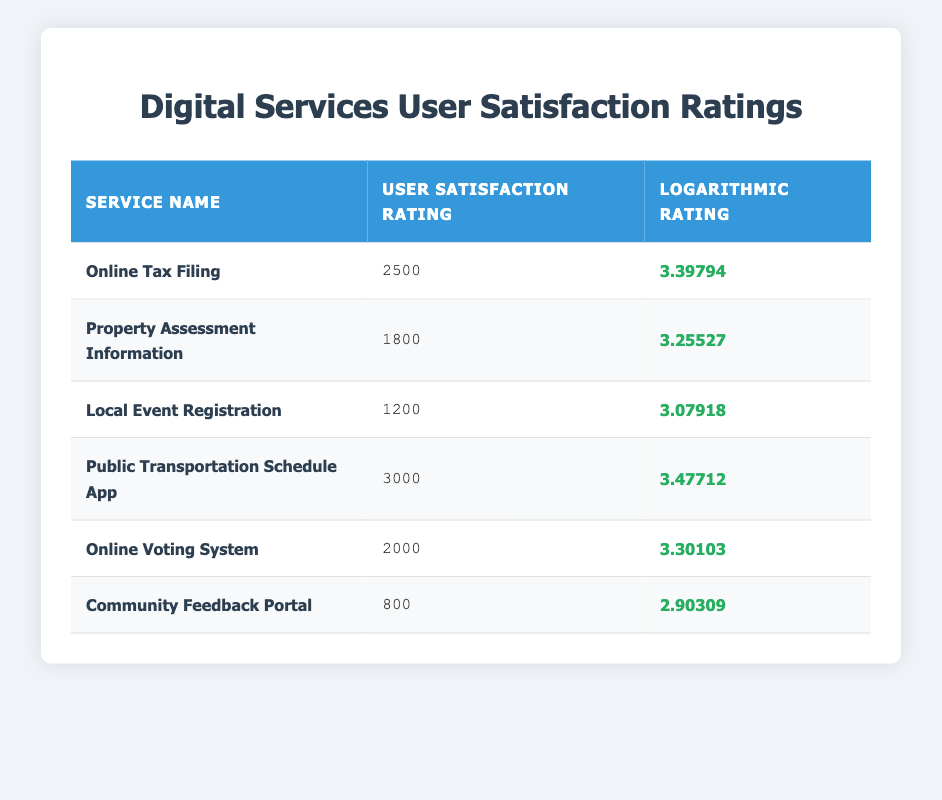What is the user satisfaction rating of the "Public Transportation Schedule App"? The table lists the "Public Transportation Schedule App" with a user satisfaction rating of 3000.
Answer: 3000 Which digital service has the lowest user satisfaction rating? By examining the user satisfaction ratings, we see that "Community Feedback Portal" has the lowest rating at 800.
Answer: Community Feedback Portal What is the difference between the user satisfaction ratings of "Online Tax Filing" and "Online Voting System"? The user satisfaction rating of "Online Tax Filing" is 2500 and for "Online Voting System" it is 2000. The difference is 2500 - 2000 = 500.
Answer: 500 Is the logarithmic rating of "Local Event Registration" greater than that of "Property Assessment Information"? The logarithmic rating for "Local Event Registration" is 3.07918 and for "Property Assessment Information" it is 3.25527. Since 3.07918 is less than 3.25527, the statement is false.
Answer: No What is the average user satisfaction rating of all listed digital services? To find the average, we first sum up all the user satisfaction ratings: 2500 + 1800 + 1200 + 3000 + 2000 + 800 = 11300. Then, we divide by the number of services, which is 6. So the average is 11300 / 6 = 1883.33.
Answer: 1883.33 Which service has a logarithmic rating closest to 3.3? Comparing logarithmic ratings, "Online Voting System" has a logarithmic rating of 3.30103, which is the closest to 3.3 when compared to "Online Tax Filing" with 3.39794 and "Property Assessment Information" with 3.25527.
Answer: Online Voting System How many digital services have a user satisfaction rating above 2000? By checking the table, the services with ratings above 2000 are "Online Tax Filing" (2500), "Public Transportation Schedule App" (3000), and "Online Voting System" (2000), adding to a total of 3 services.
Answer: 3 Is it true that the logarithmic rating of "Community Feedback Portal" is below 3? The logarithmic rating for "Community Feedback Portal" is 2.90309, which is indeed below 3, confirming the statement is true.
Answer: Yes 